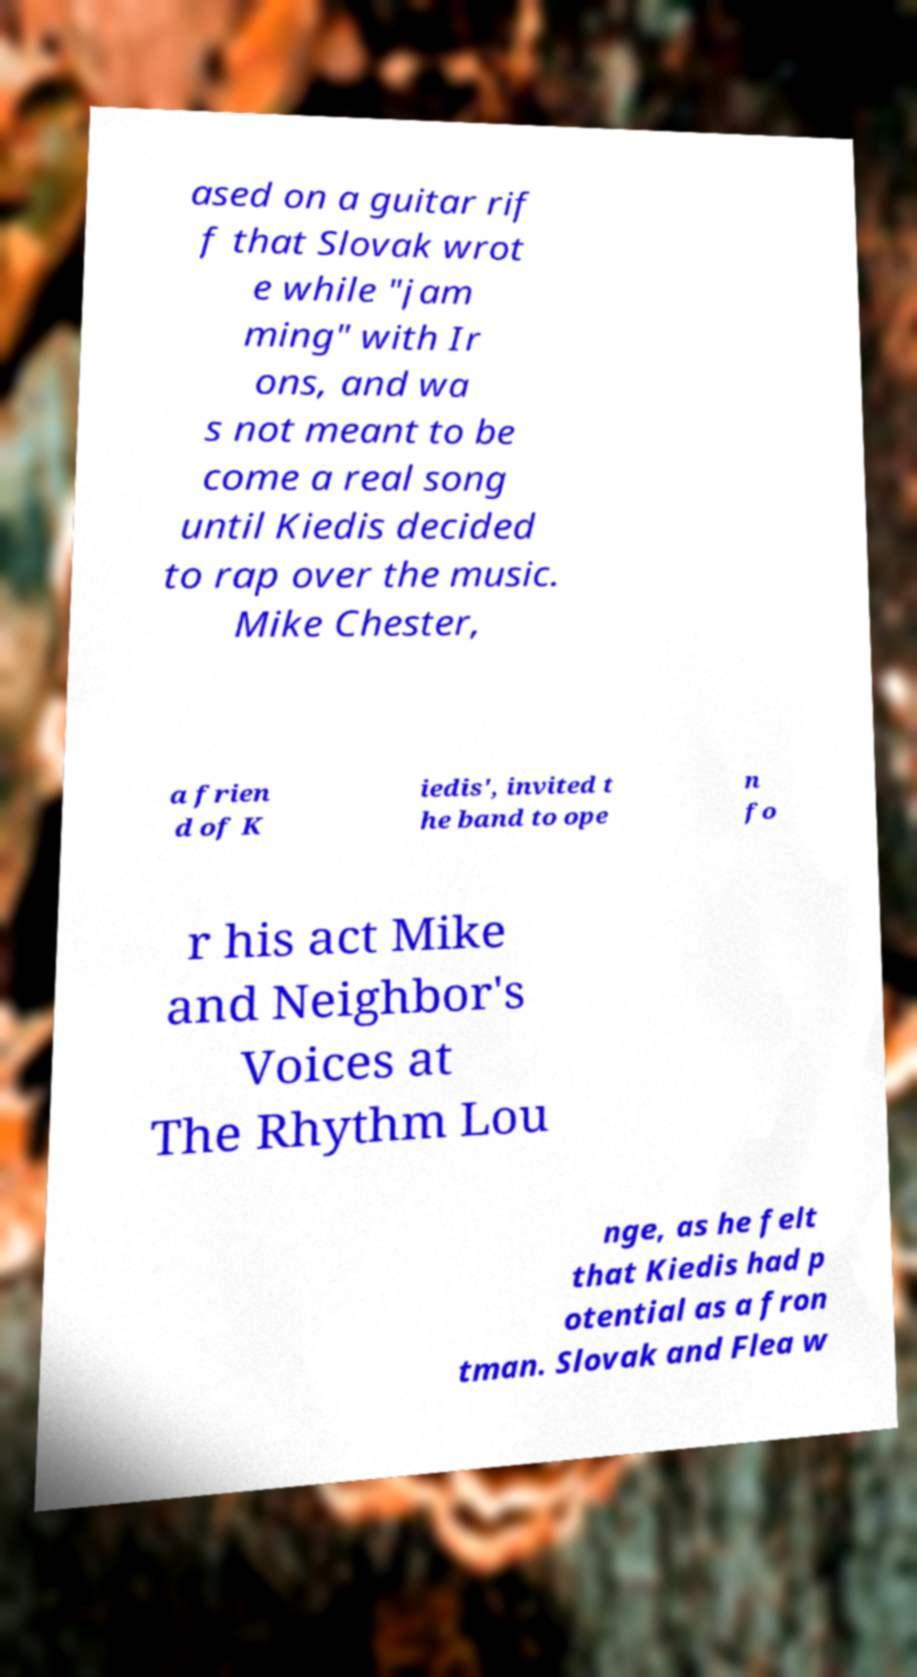For documentation purposes, I need the text within this image transcribed. Could you provide that? ased on a guitar rif f that Slovak wrot e while "jam ming" with Ir ons, and wa s not meant to be come a real song until Kiedis decided to rap over the music. Mike Chester, a frien d of K iedis', invited t he band to ope n fo r his act Mike and Neighbor's Voices at The Rhythm Lou nge, as he felt that Kiedis had p otential as a fron tman. Slovak and Flea w 